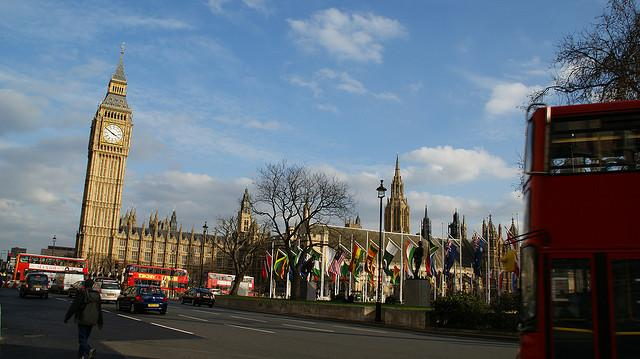Why are there so many buses? transit 